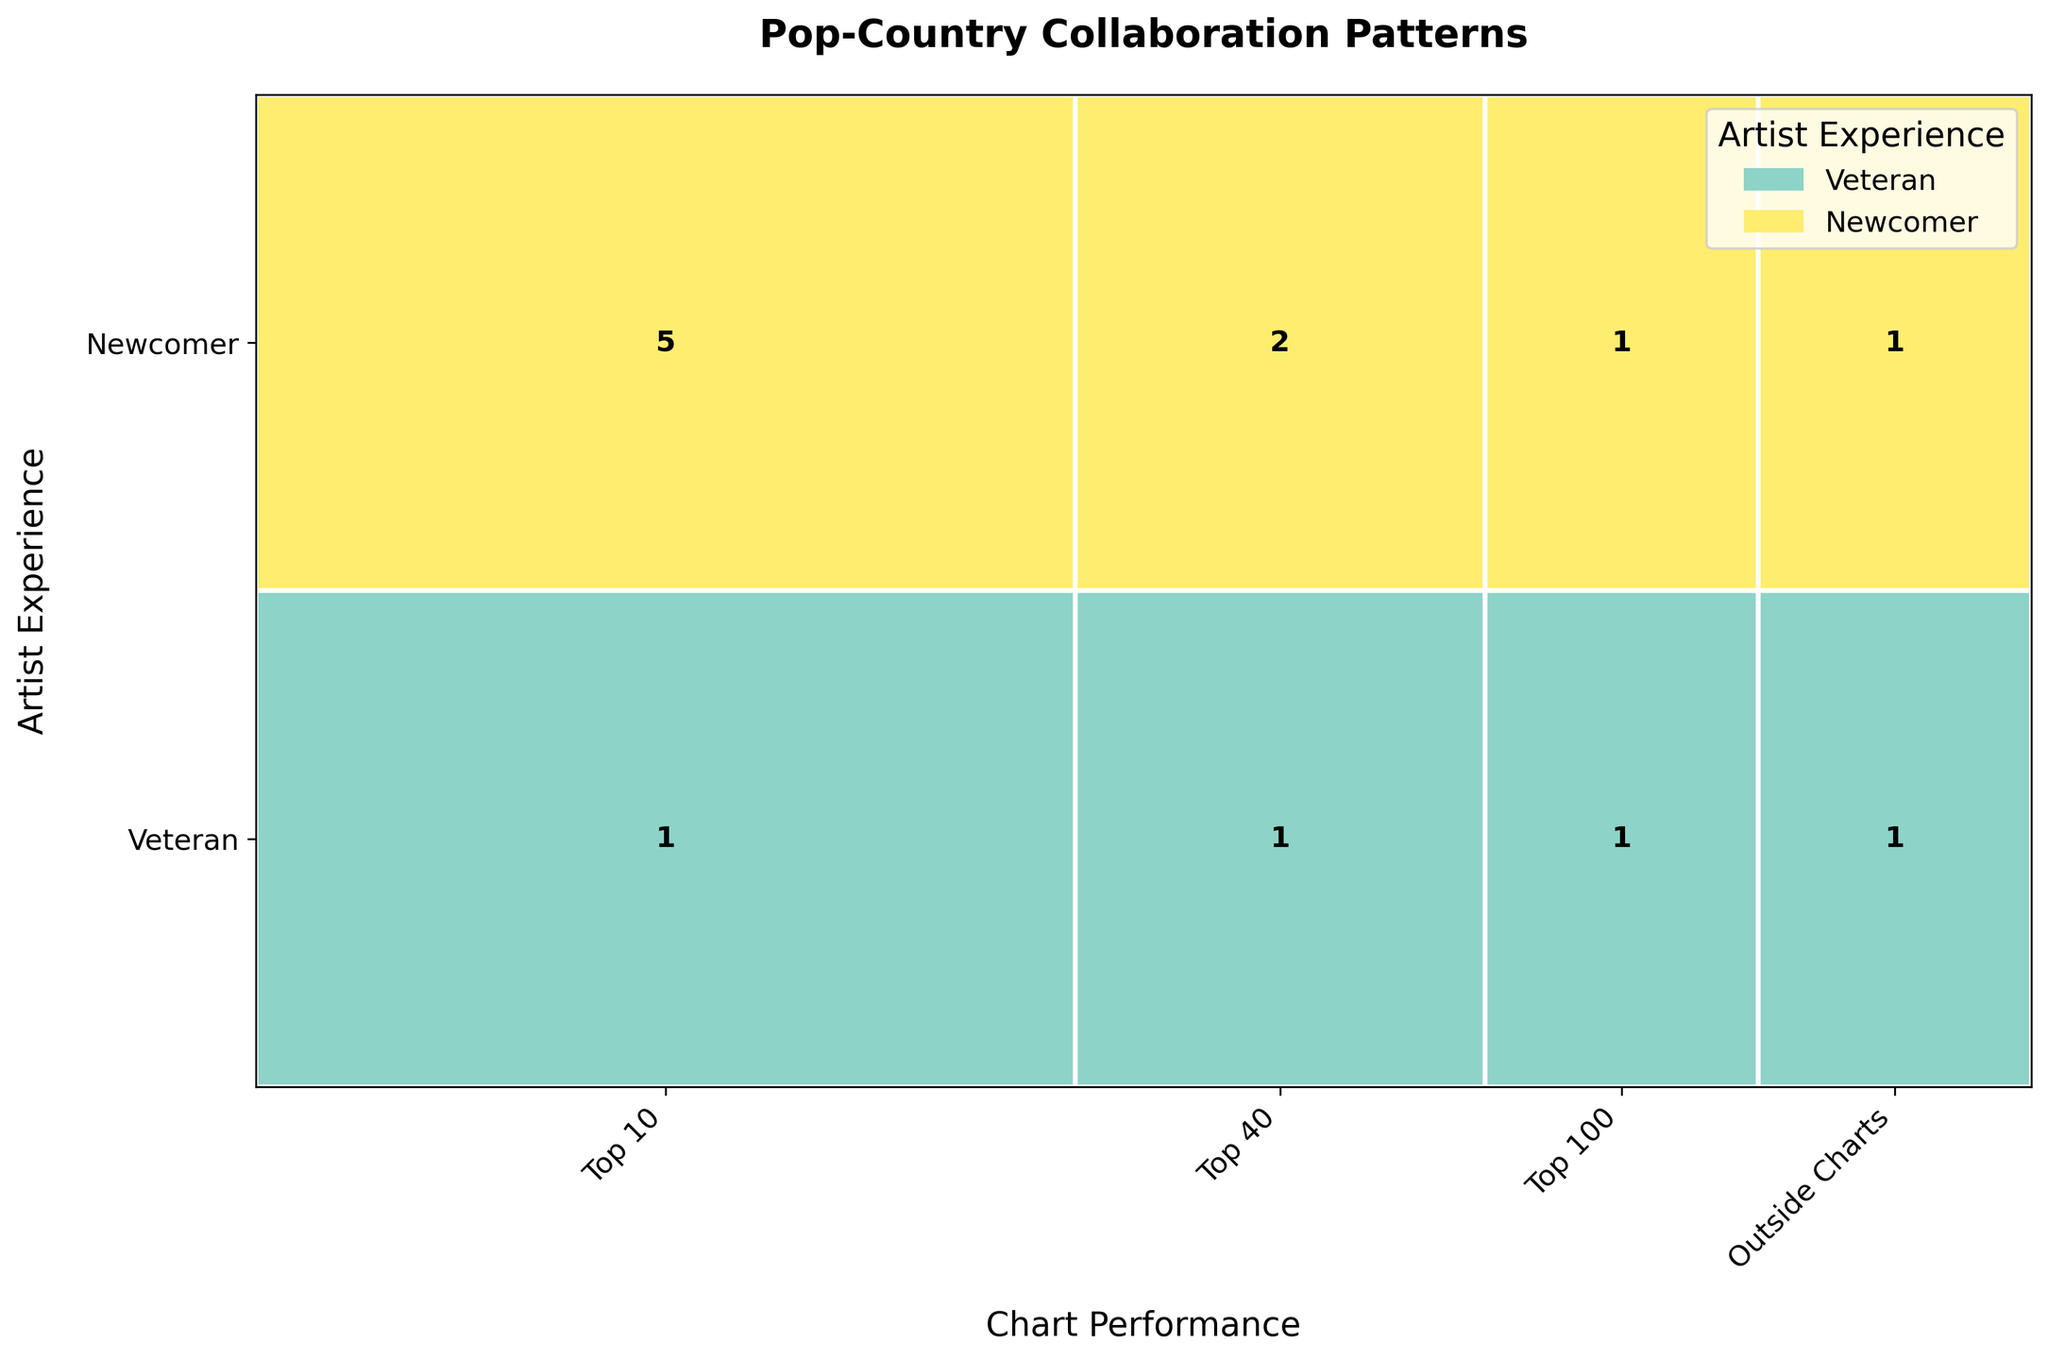What is the title of the figure? The title of the figure is usually found at the top and provides a summary of what the data represents. In this case, the figure title is "Pop-Country Collaboration Patterns".
Answer: Pop-Country Collaboration Patterns Which chart performance category has the highest number of collaborations for newcomers? To find this, refer to the bars in the figure corresponding to "Newcomer" and look for the highest value. This is the bar representing the "Top 10" category where one collaboration for newcomers is displayed.
Answer: Top 10 How many veteran collaborations made it into the Top 40 charts? Locate the "Veteran" row and then the portion of the bar representing the "Top 40" category. The number inside this segment shows there were 2 such collaborations.
Answer: 2 Which artist experience level has more collaborations in the Top 100 category? Compare the bars within the Top 100 category. Veterans have a single collaboration, and newcomers also have a single collaboration.
Answer: Equal Compare the number of veteran collaborations in the Top 10 and Top 100. Which is greater and by how much? Identify the veteran collaborations for both categories: Top 10 (3 collaborations) and Top 100 (1 collaboration). Subtracting gives 3 - 1 = 2, so there are 2 more veteran collaborations in the Top 10.
Answer: Top 10, by 2 How many total collaborations are there for veteran artists? Sum the collaborations in all categories for veteran artists: Top 10 (3 + 2), Top 40 (2), Top 100 (1), and Outside Charts (1) which totals 3 + 2 + 2 + 1 + 1 = 9.
Answer: 9 Which chart performance category has the least total number of collaborations? By assessing the individual portions representing each category, "Outside Charts" has the least total number with just 2 collaborations overall.
Answer: Outside Charts What proportion of Top 10 collaborations involve veteran artists? Divide the number of veteran collaborations in the Top 10 (3 + 2 = 5) by the total number of Top 10 collaborations (5 + 1 = 6): 5/6. Simplified, this fraction equals approximately 0.83 or 83%.
Answer: 83% How does the number of newcomer collaborations in Top 40 compare to those in Top 100? There is 1 newcomer collaboration in both Top 40 and Top 100 categories. So, the number is the same.
Answer: Equal What is the relationship between chart performance and the level of artist experience based on the figure? Analyze whether veteran or newcomer artists tend to have more collaborations in higher or lower chart performance categories. Veterans generally have more collaborations in higher chart performance categories such as Top 10 and Top 40 compared to newcomers, who have fewer or equal collaborations in these categories.
Answer: Veterans tend to have more collaborations in higher chart performance categories 